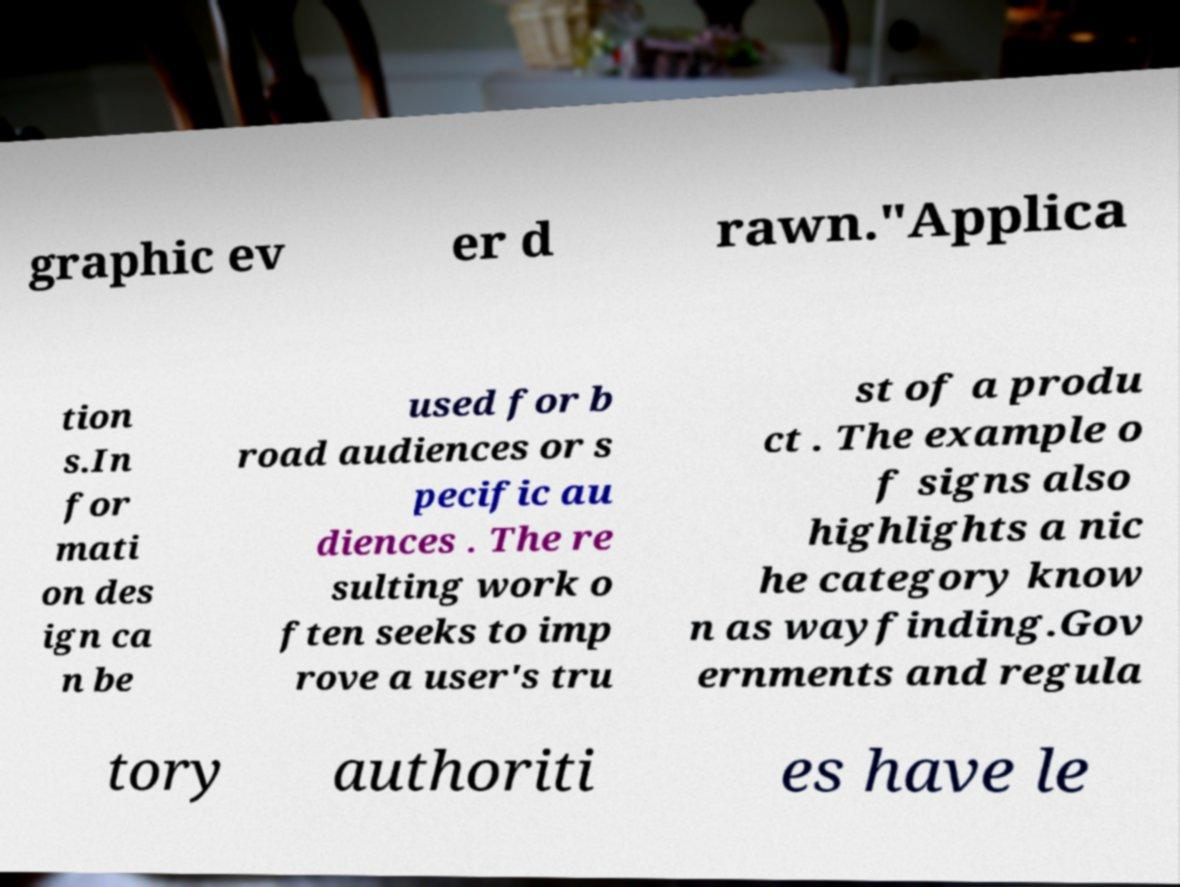Could you assist in decoding the text presented in this image and type it out clearly? graphic ev er d rawn."Applica tion s.In for mati on des ign ca n be used for b road audiences or s pecific au diences . The re sulting work o ften seeks to imp rove a user's tru st of a produ ct . The example o f signs also highlights a nic he category know n as wayfinding.Gov ernments and regula tory authoriti es have le 